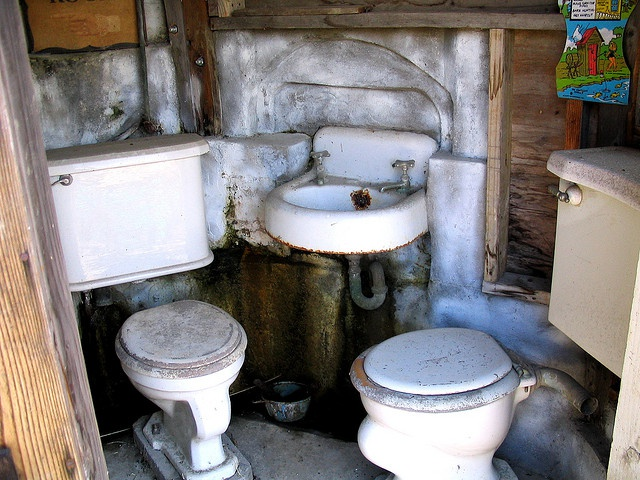Describe the objects in this image and their specific colors. I can see toilet in gray, lavender, darkgray, and black tones, toilet in gray, white, and darkgray tones, sink in gray, lavender, and darkgray tones, and bowl in gray, black, purple, and darkblue tones in this image. 